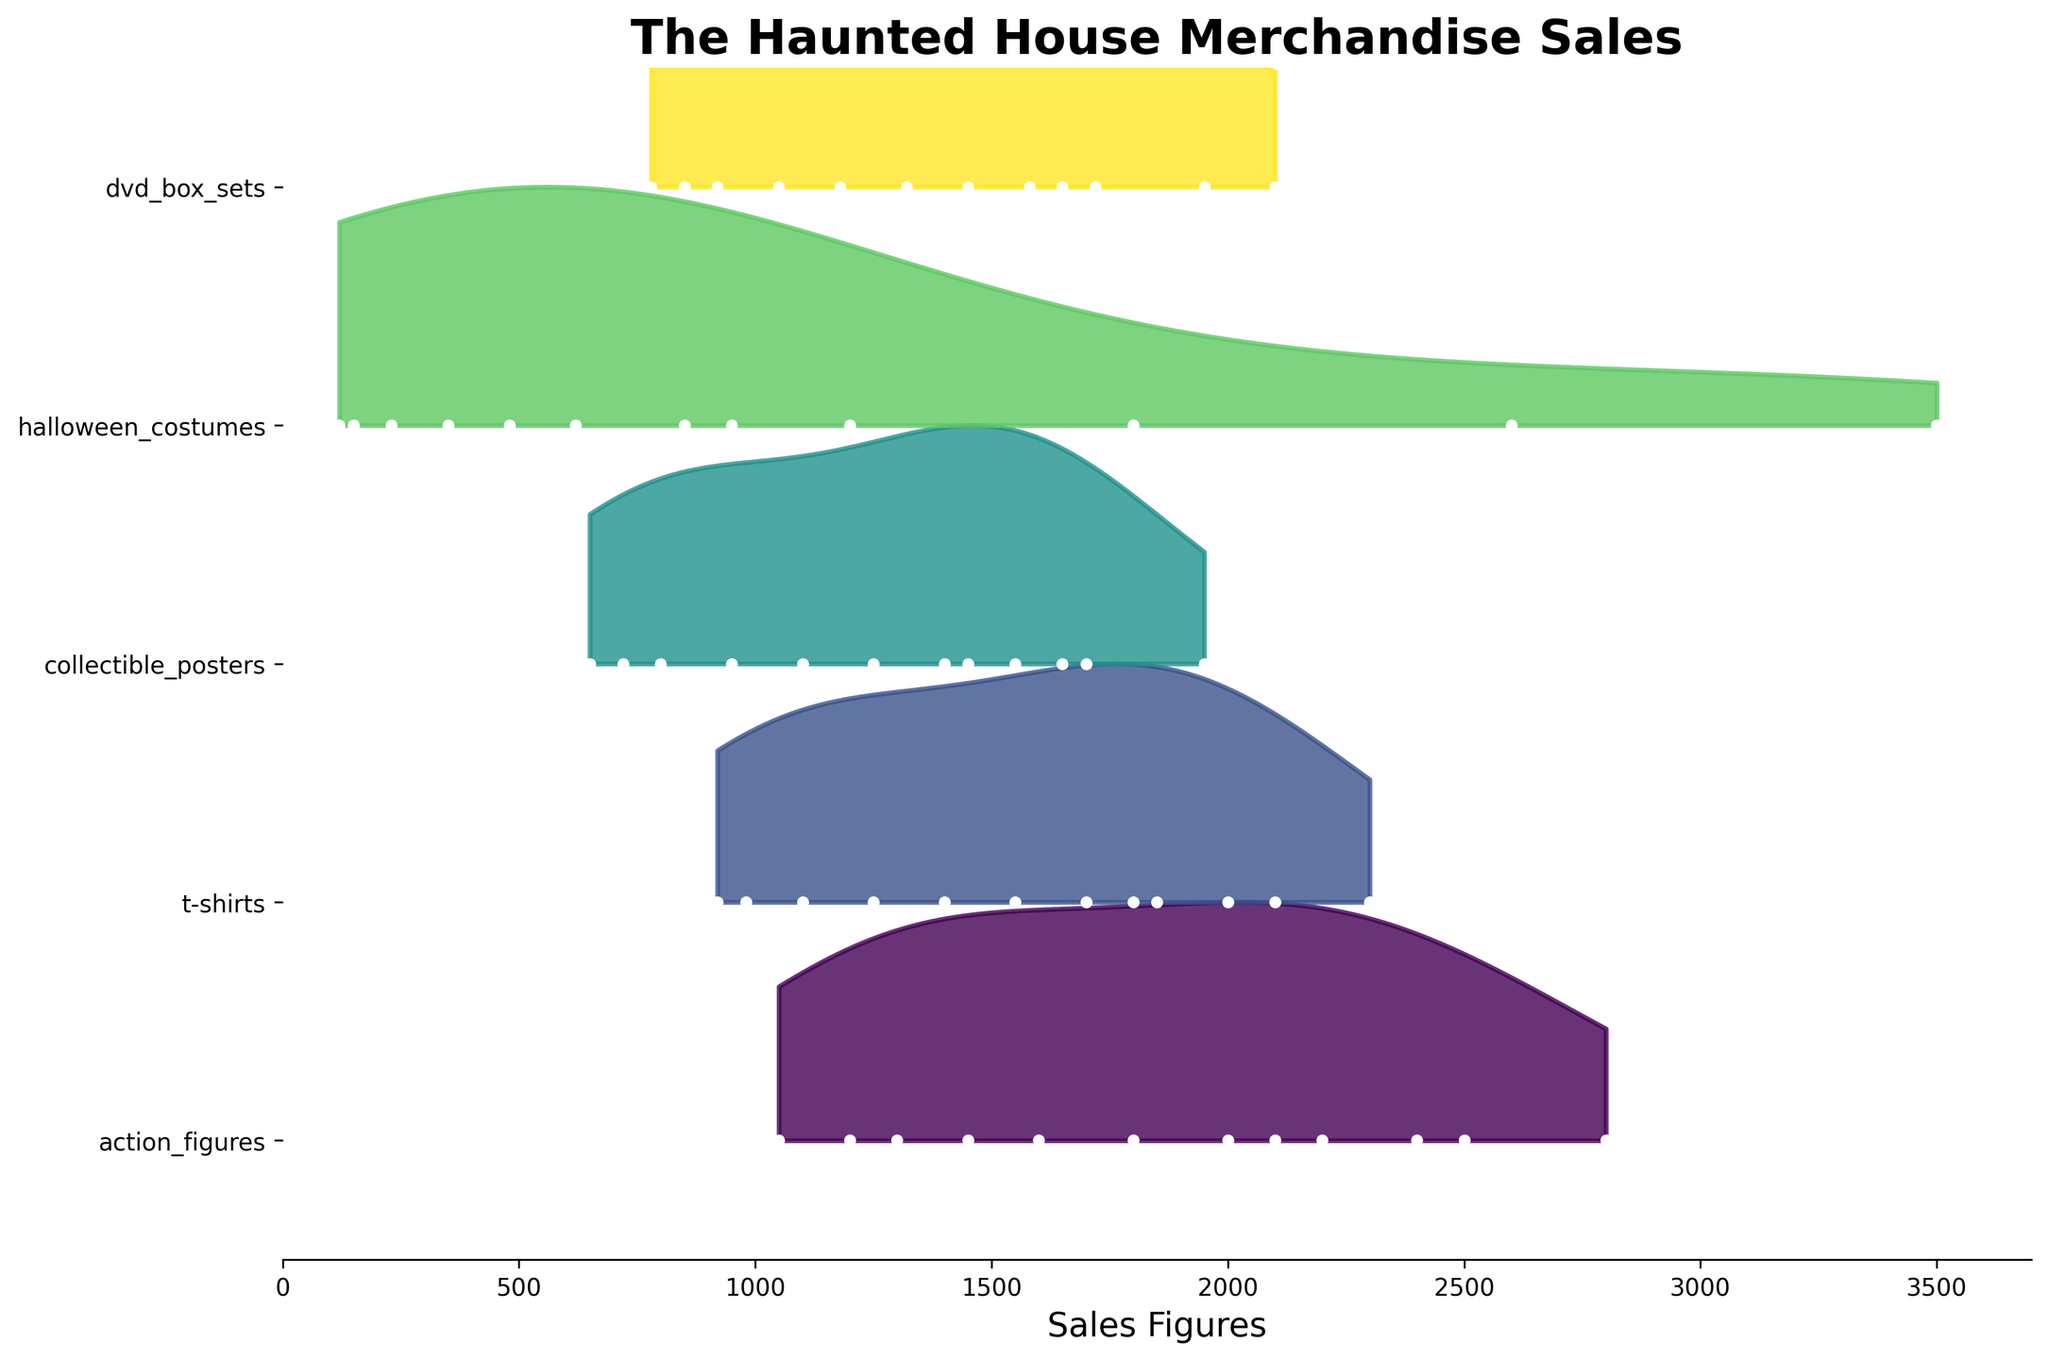what is shown on the y-axis? The y-axis lists different product categories from "The Haunted House" merchandise. Each category is plotted separately in the Ridgeline plot to show how their sales figures change over the months.
Answer: Product categories what is the color scheme used in the plot? The plot uses a gradient color scheme from the viridis color map, which transitions smoothly from one color to another across the categories.
Answer: Viridis color map Which product category has the highest peak sales? To determine the highest peak sales, visually inspect which category reaches the highest x-axis value. "Halloween costumes" show the highest peak around October.
Answer: Halloween costumes Which month shows the lowest sales for DVD box sets? Look at the DVD box sets plot, specifically at the left-most data point for the minimum value. In January, the sales figure for DVD box sets is the lowest.
Answer: January Which two months show the steepest increase in action figures' sales? Examine the action figures' plot line and identify the months with rapid upward movements. The most substantial increase occurs between July and October.
Answer: July to October What is the total sales figure for t-shirts in the first quarter of the year? Sum the monthly sales figures for t-shirts from January to March: 980 (January) + 920 (February) + 1100 (March) = 3000.
Answer: 3000 How do sales for collectible posters compare between June and September? Compare the heights of the peaks for collectible posters in June (1250) and September. The September peak (1700) is higher than June, indicating more sales.
Answer: September > June Which product category shows the most volatile sales figures across the year? Assess the spread and variation in peaks and troughs for each category. "Halloween costumes" show the most significant fluctuation, marked by substantial peaks in October and lower values in other months.
Answer: Halloween costumes What are the average sales figures for action figures over the year? Sum the action figures sales for 12 months and divide by 12:
(1200 + 1050 + 1300 + 1450 + 1600 + 1800 + 2000 + 2200 + 2400 + 2800 + 2100 + 2500) / 12 = 18608 / 12 = 1600.
Answer: 1600 